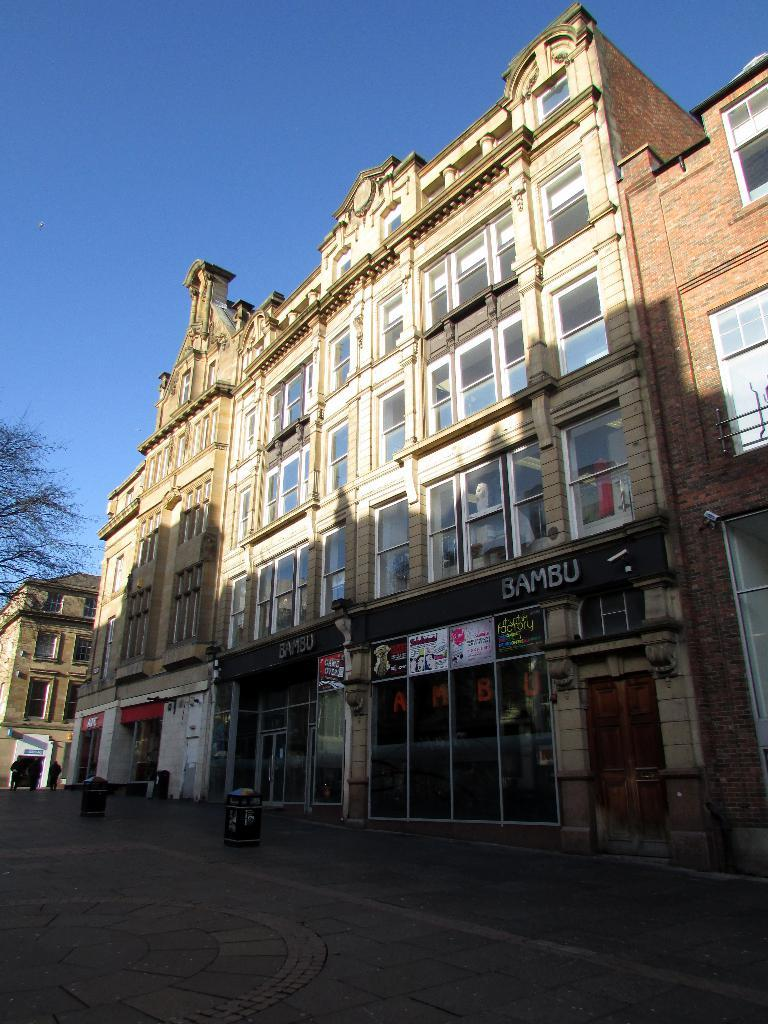What type of structures can be seen in the image? There are buildings in the image. What other objects are visible in the image besides the buildings? There are hoardings and a tree in the image. How many leaves are on the door in the image? There is no door present in the image, so it is not possible to determine the number of leaves on a door. 